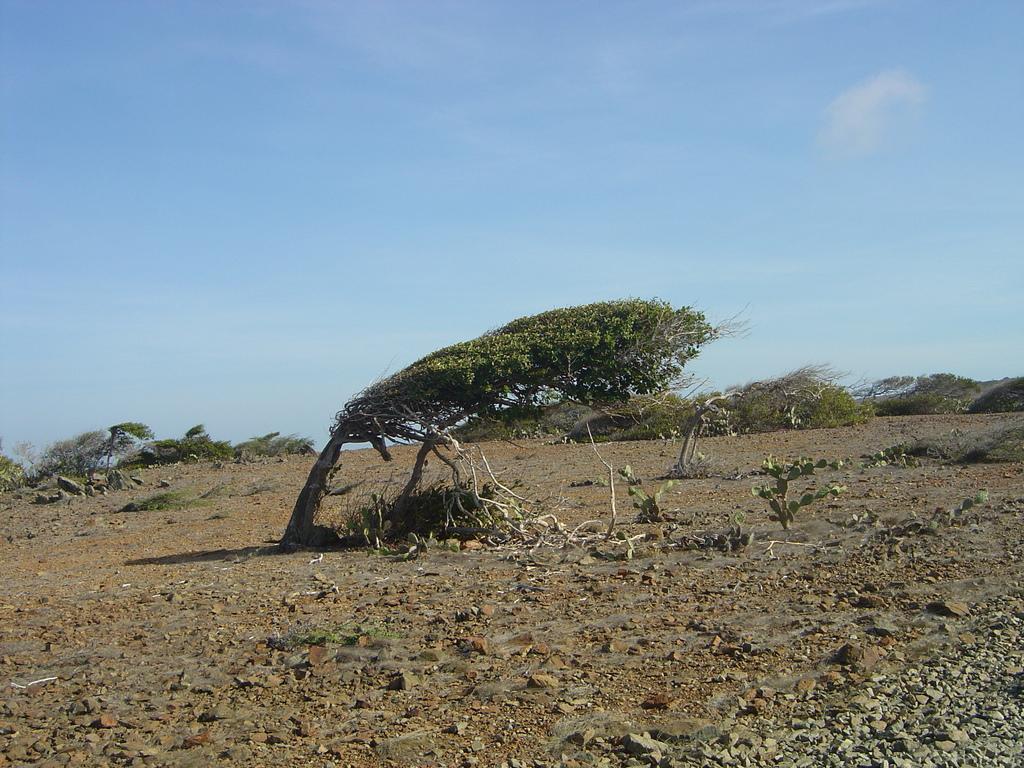Describe this image in one or two sentences. In this picture we can see some trees in a open ground. 